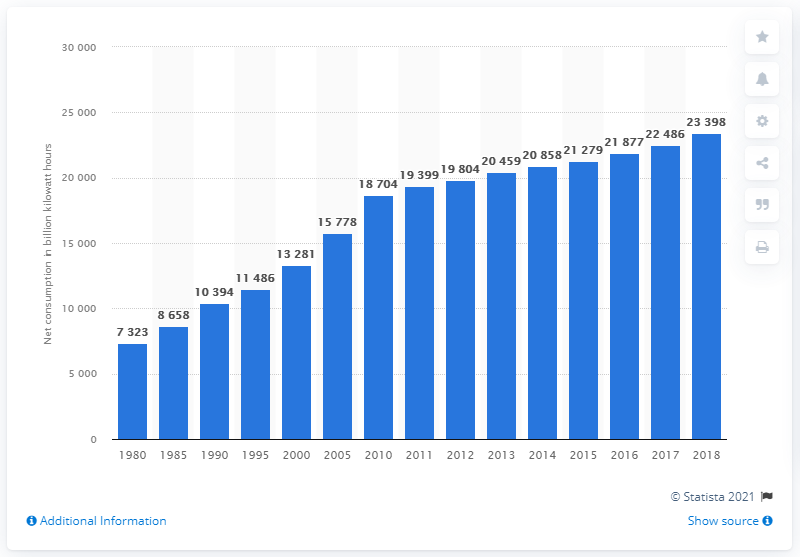Could we infer the impact of energy policies on consumption from this chart? While the chart itself primarily shows the overall trend in net electricity consumption, it indirectly reflects the impact of energy policies, especially those pertaining to energy efficiency, renewable energy adoption, and electrification of transport and heating. Policy shifts can affect consumption behaviors and investment in clean technologies, which may contribute to the variation in energy usage over time shown in the chart. 